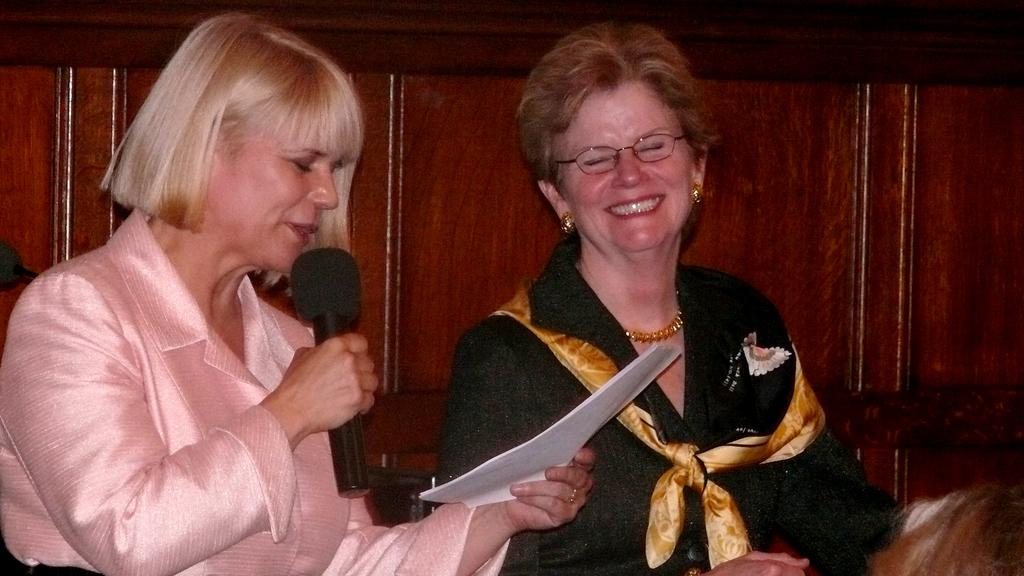What is the woman on the left side of the image holding? The woman on the left is holding a microphone and a paper. What is the woman on the left side of the image doing? The woman on the left is speaking. What is the woman on the right side of the image wearing? The woman on the right is wearing glasses, earrings, a chain, and a scarf. What is the expression of the woman on the right side of the image? The woman on the right is smiling. What can be seen in the background of the image? There is a wooden wall in the background of the image. What type of plants can be seen growing on the woman's head in the image? There are no plants visible on anyone's head in the image. What color is the blood dripping from the microphone in the image? There is no blood present in the image; the woman on the left is holding a microphone and a paper. 